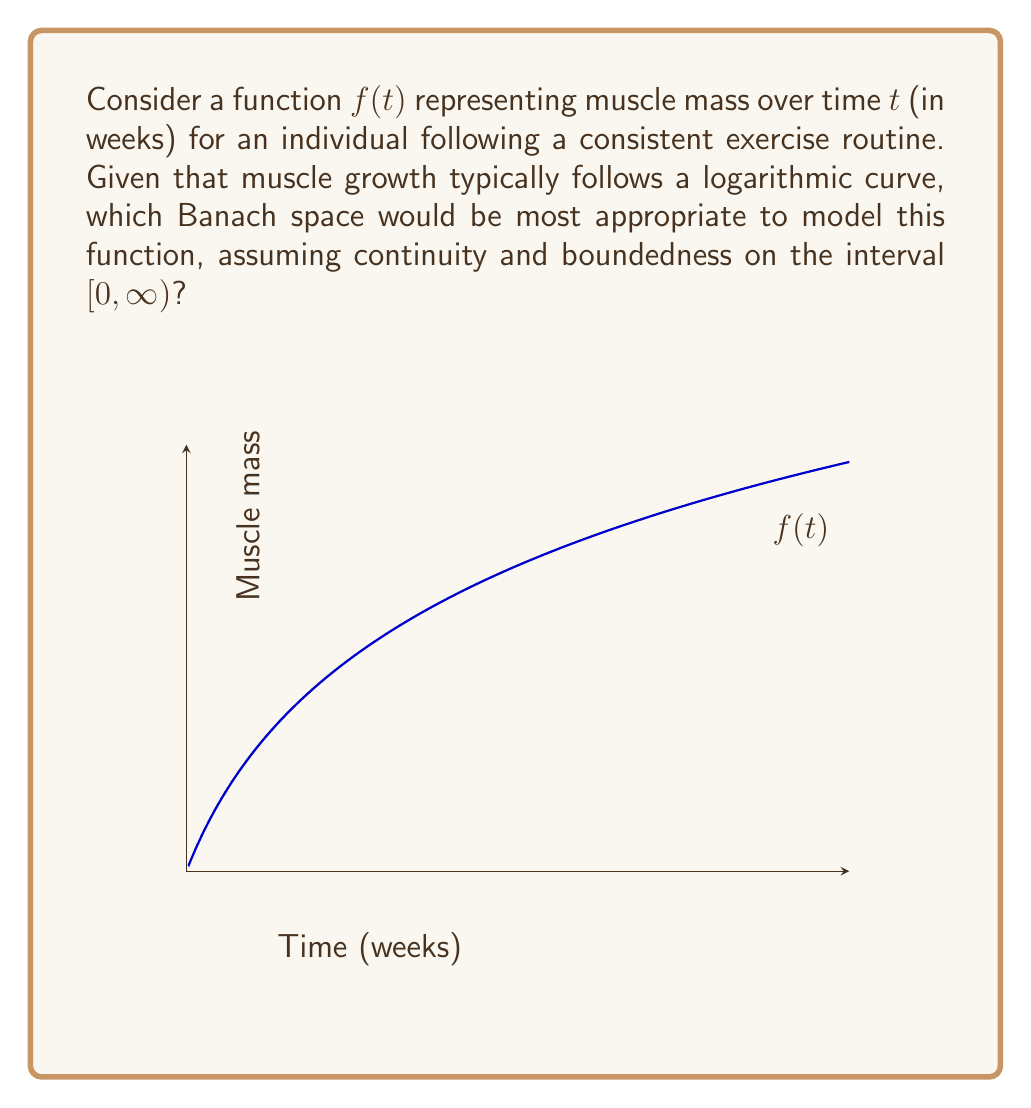Could you help me with this problem? To determine the most appropriate Banach space for modeling muscle growth over time, we need to consider the properties of the function $f(t)$ and the characteristics of various Banach spaces:

1. Domain: The function is defined on $[0, \infty)$, representing time from the start of the exercise routine.

2. Continuity: Muscle growth is a continuous process, so $f(t)$ is continuous on $[0, \infty)$.

3. Boundedness: Muscle growth has biological limits, so $f(t)$ is bounded on $[0, \infty)$.

4. Logarithmic growth: The function follows a logarithmic curve, which means it grows rapidly at first and then slows down.

Given these properties, we can consider the following Banach spaces:

a) $L^p[0, \infty)$: Not suitable because these spaces contain functions that may not be continuous or bounded.

b) $C[0, \infty)$: The space of continuous functions on $[0, \infty)$. This space is too broad as it includes unbounded functions.

c) $C_b[0, \infty)$: The space of continuous bounded functions on $[0, \infty)$. This space satisfies all our requirements:
   - It contains continuous functions.
   - It only includes bounded functions.
   - It can represent logarithmic growth.
   - It is equipped with the supremum norm: $\|f\|_{\infty} = \sup_{t \in [0, \infty)} |f(t)|$, making it a Banach space.

Therefore, the Banach space $C_b[0, \infty)$ is the most appropriate for modeling muscle growth over time.
Answer: $C_b[0, \infty)$ 